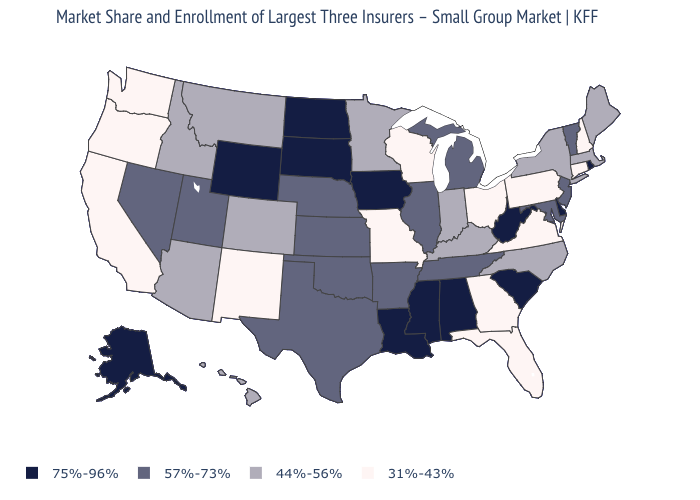Which states have the lowest value in the USA?
Write a very short answer. California, Connecticut, Florida, Georgia, Missouri, New Hampshire, New Mexico, Ohio, Oregon, Pennsylvania, Virginia, Washington, Wisconsin. What is the lowest value in the USA?
Keep it brief. 31%-43%. Does Connecticut have the lowest value in the USA?
Be succinct. Yes. Is the legend a continuous bar?
Give a very brief answer. No. What is the highest value in the Northeast ?
Short answer required. 75%-96%. Does the first symbol in the legend represent the smallest category?
Concise answer only. No. Among the states that border Indiana , does Ohio have the highest value?
Short answer required. No. Name the states that have a value in the range 31%-43%?
Be succinct. California, Connecticut, Florida, Georgia, Missouri, New Hampshire, New Mexico, Ohio, Oregon, Pennsylvania, Virginia, Washington, Wisconsin. What is the highest value in the USA?
Concise answer only. 75%-96%. Name the states that have a value in the range 44%-56%?
Give a very brief answer. Arizona, Colorado, Hawaii, Idaho, Indiana, Kentucky, Maine, Massachusetts, Minnesota, Montana, New York, North Carolina. How many symbols are there in the legend?
Short answer required. 4. What is the value of Illinois?
Keep it brief. 57%-73%. Does the map have missing data?
Be succinct. No. Name the states that have a value in the range 75%-96%?
Give a very brief answer. Alabama, Alaska, Delaware, Iowa, Louisiana, Mississippi, North Dakota, Rhode Island, South Carolina, South Dakota, West Virginia, Wyoming. Name the states that have a value in the range 75%-96%?
Be succinct. Alabama, Alaska, Delaware, Iowa, Louisiana, Mississippi, North Dakota, Rhode Island, South Carolina, South Dakota, West Virginia, Wyoming. 